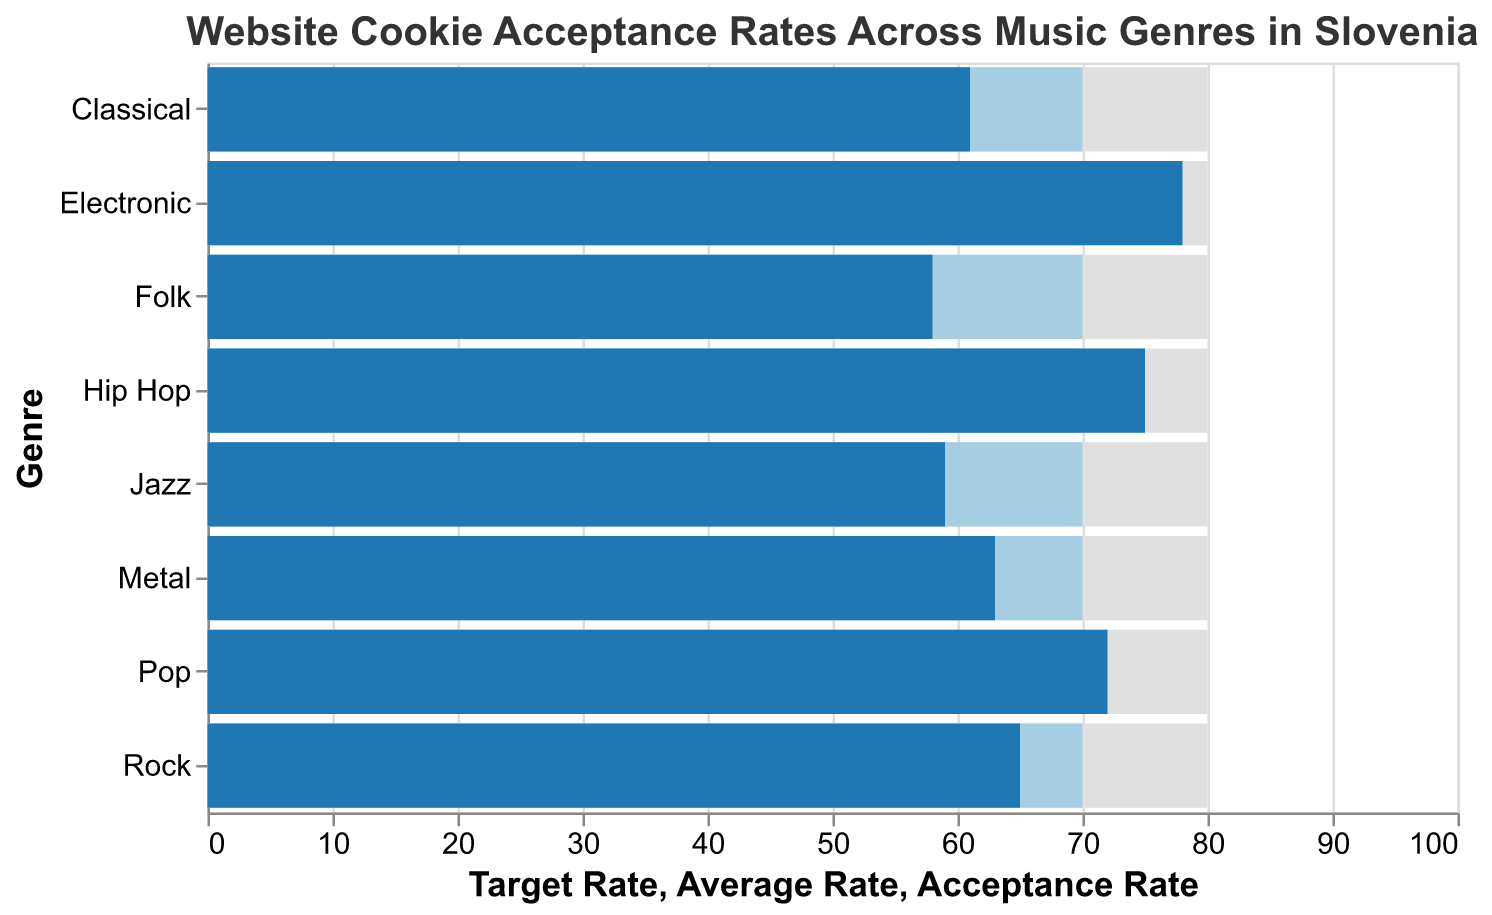What is the title of the figure? The title of the figure is shown at the top of the chart, providing a summary of the data visualized.
Answer: Website Cookie Acceptance Rates Across Music Genres in Slovenia Which genre has the highest acceptance rate? Look at the bars representing the acceptance rates in the "Acceptance Rate" column and identify the tallest one.
Answer: Electronic What is the acceptance rate for Jazz? Locate the bar corresponding to Jazz in the figure and read the value from the "Acceptance Rate" bar.
Answer: 59 How many genres have an acceptance rate higher than the average rate? Compare each acceptance rate to the average rate of 70. Count the number of genres where the acceptance rate is greater than 70.
Answer: 3 What is the target rate across all genres? The target rate is a constant value indicated by identical bars.
Answer: 80 What is the difference in acceptance rate between Electronic and Folk? Subtract the acceptance rate of Folk from the acceptance rate of Electronic: 78 - 58.
Answer: 20 Which genres have an acceptance rate below the target rate? Check each genre's acceptance rate and compare it to the target rate of 80. Only include those with an acceptance rate lower than 80.
Answer: Rock, Pop, Folk, Classical, Jazz, Hip Hop, Metal How much lower is the Rock acceptance rate compared to the target rate? Subtract the Rock acceptance rate from the target rate: 80 - 65.
Answer: 15 What is the visual representation (color) used for the average rate in the chart? Identify the color used for all average rate bars and describe it.
Answer: Light blue Which genre's acceptance rate is closest to the average rate? Compare each genre's acceptance rate to the average rate (70) and find the smallest difference.
Answer: Pop 